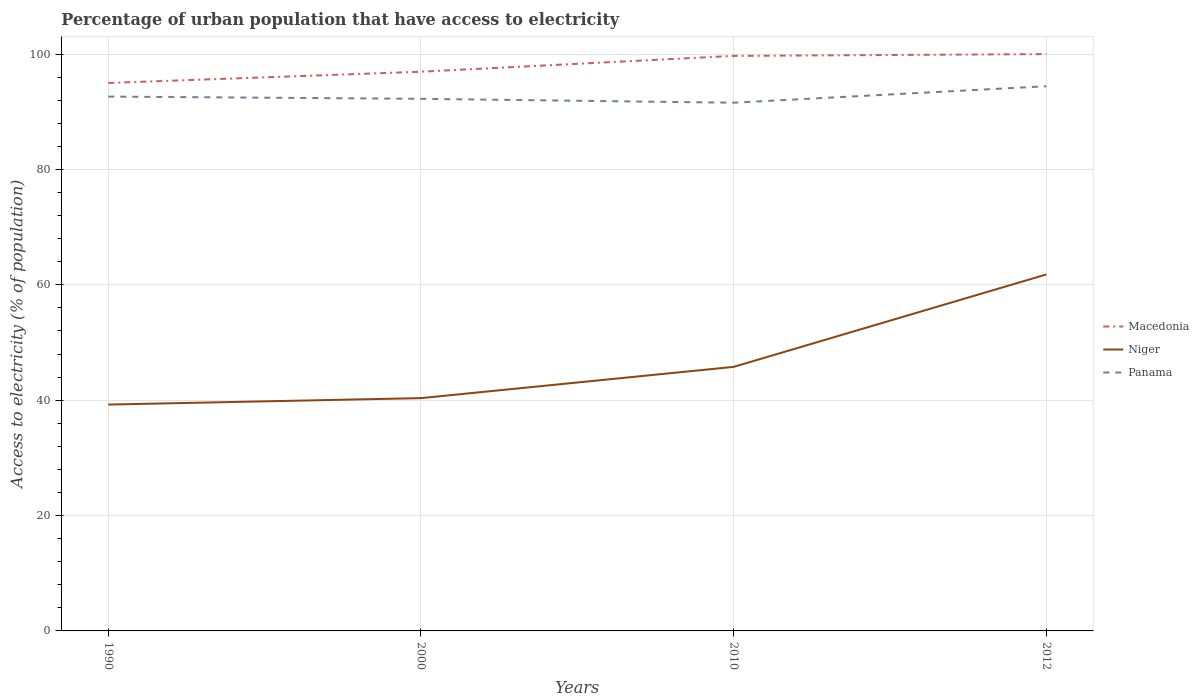How many different coloured lines are there?
Ensure brevity in your answer.  3. Across all years, what is the maximum percentage of urban population that have access to electricity in Panama?
Make the answer very short. 91.57. In which year was the percentage of urban population that have access to electricity in Niger maximum?
Provide a short and direct response. 1990. What is the total percentage of urban population that have access to electricity in Panama in the graph?
Ensure brevity in your answer.  -2.18. What is the difference between the highest and the second highest percentage of urban population that have access to electricity in Macedonia?
Keep it short and to the point. 5.01. What is the difference between the highest and the lowest percentage of urban population that have access to electricity in Niger?
Make the answer very short. 1. Is the percentage of urban population that have access to electricity in Niger strictly greater than the percentage of urban population that have access to electricity in Panama over the years?
Provide a succinct answer. Yes. How many lines are there?
Your response must be concise. 3. Where does the legend appear in the graph?
Give a very brief answer. Center right. What is the title of the graph?
Make the answer very short. Percentage of urban population that have access to electricity. What is the label or title of the Y-axis?
Give a very brief answer. Access to electricity (% of population). What is the Access to electricity (% of population) of Macedonia in 1990?
Ensure brevity in your answer.  94.99. What is the Access to electricity (% of population) in Niger in 1990?
Give a very brief answer. 39.24. What is the Access to electricity (% of population) in Panama in 1990?
Provide a short and direct response. 92.63. What is the Access to electricity (% of population) of Macedonia in 2000?
Offer a terse response. 96.95. What is the Access to electricity (% of population) of Niger in 2000?
Provide a succinct answer. 40.36. What is the Access to electricity (% of population) of Panama in 2000?
Make the answer very short. 92.25. What is the Access to electricity (% of population) in Macedonia in 2010?
Your answer should be very brief. 99.69. What is the Access to electricity (% of population) of Niger in 2010?
Provide a succinct answer. 45.78. What is the Access to electricity (% of population) of Panama in 2010?
Make the answer very short. 91.57. What is the Access to electricity (% of population) of Niger in 2012?
Ensure brevity in your answer.  61.8. What is the Access to electricity (% of population) of Panama in 2012?
Ensure brevity in your answer.  94.43. Across all years, what is the maximum Access to electricity (% of population) of Niger?
Make the answer very short. 61.8. Across all years, what is the maximum Access to electricity (% of population) of Panama?
Your answer should be very brief. 94.43. Across all years, what is the minimum Access to electricity (% of population) of Macedonia?
Offer a terse response. 94.99. Across all years, what is the minimum Access to electricity (% of population) in Niger?
Ensure brevity in your answer.  39.24. Across all years, what is the minimum Access to electricity (% of population) in Panama?
Keep it short and to the point. 91.57. What is the total Access to electricity (% of population) of Macedonia in the graph?
Provide a succinct answer. 391.63. What is the total Access to electricity (% of population) in Niger in the graph?
Provide a short and direct response. 187.18. What is the total Access to electricity (% of population) in Panama in the graph?
Offer a terse response. 370.88. What is the difference between the Access to electricity (% of population) in Macedonia in 1990 and that in 2000?
Offer a terse response. -1.95. What is the difference between the Access to electricity (% of population) in Niger in 1990 and that in 2000?
Your answer should be very brief. -1.12. What is the difference between the Access to electricity (% of population) in Panama in 1990 and that in 2000?
Ensure brevity in your answer.  0.39. What is the difference between the Access to electricity (% of population) in Macedonia in 1990 and that in 2010?
Make the answer very short. -4.7. What is the difference between the Access to electricity (% of population) in Niger in 1990 and that in 2010?
Make the answer very short. -6.54. What is the difference between the Access to electricity (% of population) in Panama in 1990 and that in 2010?
Provide a succinct answer. 1.06. What is the difference between the Access to electricity (% of population) of Macedonia in 1990 and that in 2012?
Give a very brief answer. -5.01. What is the difference between the Access to electricity (% of population) in Niger in 1990 and that in 2012?
Your response must be concise. -22.56. What is the difference between the Access to electricity (% of population) of Panama in 1990 and that in 2012?
Keep it short and to the point. -1.8. What is the difference between the Access to electricity (% of population) of Macedonia in 2000 and that in 2010?
Offer a terse response. -2.74. What is the difference between the Access to electricity (% of population) in Niger in 2000 and that in 2010?
Provide a succinct answer. -5.42. What is the difference between the Access to electricity (% of population) in Panama in 2000 and that in 2010?
Offer a very short reply. 0.67. What is the difference between the Access to electricity (% of population) in Macedonia in 2000 and that in 2012?
Keep it short and to the point. -3.06. What is the difference between the Access to electricity (% of population) of Niger in 2000 and that in 2012?
Your answer should be very brief. -21.44. What is the difference between the Access to electricity (% of population) in Panama in 2000 and that in 2012?
Your response must be concise. -2.18. What is the difference between the Access to electricity (% of population) in Macedonia in 2010 and that in 2012?
Give a very brief answer. -0.31. What is the difference between the Access to electricity (% of population) in Niger in 2010 and that in 2012?
Keep it short and to the point. -16.02. What is the difference between the Access to electricity (% of population) in Panama in 2010 and that in 2012?
Keep it short and to the point. -2.86. What is the difference between the Access to electricity (% of population) in Macedonia in 1990 and the Access to electricity (% of population) in Niger in 2000?
Your answer should be very brief. 54.64. What is the difference between the Access to electricity (% of population) of Macedonia in 1990 and the Access to electricity (% of population) of Panama in 2000?
Keep it short and to the point. 2.75. What is the difference between the Access to electricity (% of population) in Niger in 1990 and the Access to electricity (% of population) in Panama in 2000?
Your response must be concise. -53.01. What is the difference between the Access to electricity (% of population) of Macedonia in 1990 and the Access to electricity (% of population) of Niger in 2010?
Your response must be concise. 49.22. What is the difference between the Access to electricity (% of population) of Macedonia in 1990 and the Access to electricity (% of population) of Panama in 2010?
Your response must be concise. 3.42. What is the difference between the Access to electricity (% of population) of Niger in 1990 and the Access to electricity (% of population) of Panama in 2010?
Your answer should be compact. -52.33. What is the difference between the Access to electricity (% of population) of Macedonia in 1990 and the Access to electricity (% of population) of Niger in 2012?
Ensure brevity in your answer.  33.19. What is the difference between the Access to electricity (% of population) of Macedonia in 1990 and the Access to electricity (% of population) of Panama in 2012?
Offer a very short reply. 0.56. What is the difference between the Access to electricity (% of population) of Niger in 1990 and the Access to electricity (% of population) of Panama in 2012?
Offer a terse response. -55.19. What is the difference between the Access to electricity (% of population) of Macedonia in 2000 and the Access to electricity (% of population) of Niger in 2010?
Keep it short and to the point. 51.17. What is the difference between the Access to electricity (% of population) in Macedonia in 2000 and the Access to electricity (% of population) in Panama in 2010?
Provide a succinct answer. 5.37. What is the difference between the Access to electricity (% of population) in Niger in 2000 and the Access to electricity (% of population) in Panama in 2010?
Your answer should be compact. -51.22. What is the difference between the Access to electricity (% of population) in Macedonia in 2000 and the Access to electricity (% of population) in Niger in 2012?
Offer a terse response. 35.15. What is the difference between the Access to electricity (% of population) in Macedonia in 2000 and the Access to electricity (% of population) in Panama in 2012?
Your answer should be very brief. 2.52. What is the difference between the Access to electricity (% of population) of Niger in 2000 and the Access to electricity (% of population) of Panama in 2012?
Your answer should be very brief. -54.07. What is the difference between the Access to electricity (% of population) of Macedonia in 2010 and the Access to electricity (% of population) of Niger in 2012?
Make the answer very short. 37.89. What is the difference between the Access to electricity (% of population) of Macedonia in 2010 and the Access to electricity (% of population) of Panama in 2012?
Your response must be concise. 5.26. What is the difference between the Access to electricity (% of population) of Niger in 2010 and the Access to electricity (% of population) of Panama in 2012?
Offer a terse response. -48.65. What is the average Access to electricity (% of population) in Macedonia per year?
Provide a succinct answer. 97.91. What is the average Access to electricity (% of population) of Niger per year?
Give a very brief answer. 46.79. What is the average Access to electricity (% of population) of Panama per year?
Provide a short and direct response. 92.72. In the year 1990, what is the difference between the Access to electricity (% of population) of Macedonia and Access to electricity (% of population) of Niger?
Your answer should be compact. 55.75. In the year 1990, what is the difference between the Access to electricity (% of population) of Macedonia and Access to electricity (% of population) of Panama?
Make the answer very short. 2.36. In the year 1990, what is the difference between the Access to electricity (% of population) of Niger and Access to electricity (% of population) of Panama?
Your answer should be very brief. -53.39. In the year 2000, what is the difference between the Access to electricity (% of population) in Macedonia and Access to electricity (% of population) in Niger?
Give a very brief answer. 56.59. In the year 2000, what is the difference between the Access to electricity (% of population) in Macedonia and Access to electricity (% of population) in Panama?
Your answer should be very brief. 4.7. In the year 2000, what is the difference between the Access to electricity (% of population) of Niger and Access to electricity (% of population) of Panama?
Provide a succinct answer. -51.89. In the year 2010, what is the difference between the Access to electricity (% of population) of Macedonia and Access to electricity (% of population) of Niger?
Provide a short and direct response. 53.91. In the year 2010, what is the difference between the Access to electricity (% of population) in Macedonia and Access to electricity (% of population) in Panama?
Offer a terse response. 8.12. In the year 2010, what is the difference between the Access to electricity (% of population) of Niger and Access to electricity (% of population) of Panama?
Ensure brevity in your answer.  -45.8. In the year 2012, what is the difference between the Access to electricity (% of population) in Macedonia and Access to electricity (% of population) in Niger?
Your answer should be very brief. 38.2. In the year 2012, what is the difference between the Access to electricity (% of population) of Macedonia and Access to electricity (% of population) of Panama?
Provide a short and direct response. 5.57. In the year 2012, what is the difference between the Access to electricity (% of population) in Niger and Access to electricity (% of population) in Panama?
Your answer should be very brief. -32.63. What is the ratio of the Access to electricity (% of population) of Macedonia in 1990 to that in 2000?
Make the answer very short. 0.98. What is the ratio of the Access to electricity (% of population) of Niger in 1990 to that in 2000?
Your answer should be compact. 0.97. What is the ratio of the Access to electricity (% of population) of Panama in 1990 to that in 2000?
Ensure brevity in your answer.  1. What is the ratio of the Access to electricity (% of population) of Macedonia in 1990 to that in 2010?
Offer a very short reply. 0.95. What is the ratio of the Access to electricity (% of population) of Niger in 1990 to that in 2010?
Offer a terse response. 0.86. What is the ratio of the Access to electricity (% of population) of Panama in 1990 to that in 2010?
Your answer should be very brief. 1.01. What is the ratio of the Access to electricity (% of population) of Macedonia in 1990 to that in 2012?
Provide a short and direct response. 0.95. What is the ratio of the Access to electricity (% of population) of Niger in 1990 to that in 2012?
Provide a succinct answer. 0.64. What is the ratio of the Access to electricity (% of population) of Panama in 1990 to that in 2012?
Keep it short and to the point. 0.98. What is the ratio of the Access to electricity (% of population) of Macedonia in 2000 to that in 2010?
Your response must be concise. 0.97. What is the ratio of the Access to electricity (% of population) in Niger in 2000 to that in 2010?
Your answer should be compact. 0.88. What is the ratio of the Access to electricity (% of population) in Panama in 2000 to that in 2010?
Your response must be concise. 1.01. What is the ratio of the Access to electricity (% of population) of Macedonia in 2000 to that in 2012?
Keep it short and to the point. 0.97. What is the ratio of the Access to electricity (% of population) in Niger in 2000 to that in 2012?
Give a very brief answer. 0.65. What is the ratio of the Access to electricity (% of population) of Panama in 2000 to that in 2012?
Give a very brief answer. 0.98. What is the ratio of the Access to electricity (% of population) of Niger in 2010 to that in 2012?
Provide a succinct answer. 0.74. What is the ratio of the Access to electricity (% of population) of Panama in 2010 to that in 2012?
Give a very brief answer. 0.97. What is the difference between the highest and the second highest Access to electricity (% of population) of Macedonia?
Offer a terse response. 0.31. What is the difference between the highest and the second highest Access to electricity (% of population) of Niger?
Make the answer very short. 16.02. What is the difference between the highest and the second highest Access to electricity (% of population) of Panama?
Provide a succinct answer. 1.8. What is the difference between the highest and the lowest Access to electricity (% of population) of Macedonia?
Provide a succinct answer. 5.01. What is the difference between the highest and the lowest Access to electricity (% of population) in Niger?
Ensure brevity in your answer.  22.56. What is the difference between the highest and the lowest Access to electricity (% of population) of Panama?
Your answer should be compact. 2.86. 